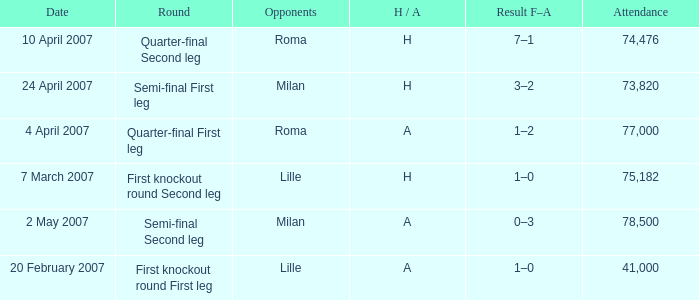Parse the table in full. {'header': ['Date', 'Round', 'Opponents', 'H / A', 'Result F–A', 'Attendance'], 'rows': [['10 April 2007', 'Quarter-final Second leg', 'Roma', 'H', '7–1', '74,476'], ['24 April 2007', 'Semi-final First leg', 'Milan', 'H', '3–2', '73,820'], ['4 April 2007', 'Quarter-final First leg', 'Roma', 'A', '1–2', '77,000'], ['7 March 2007', 'First knockout round Second leg', 'Lille', 'H', '1–0', '75,182'], ['2 May 2007', 'Semi-final Second leg', 'Milan', 'A', '0–3', '78,500'], ['20 February 2007', 'First knockout round First leg', 'Lille', 'A', '1–0', '41,000']]} Which round happened on 10 april 2007? Quarter-final Second leg. 